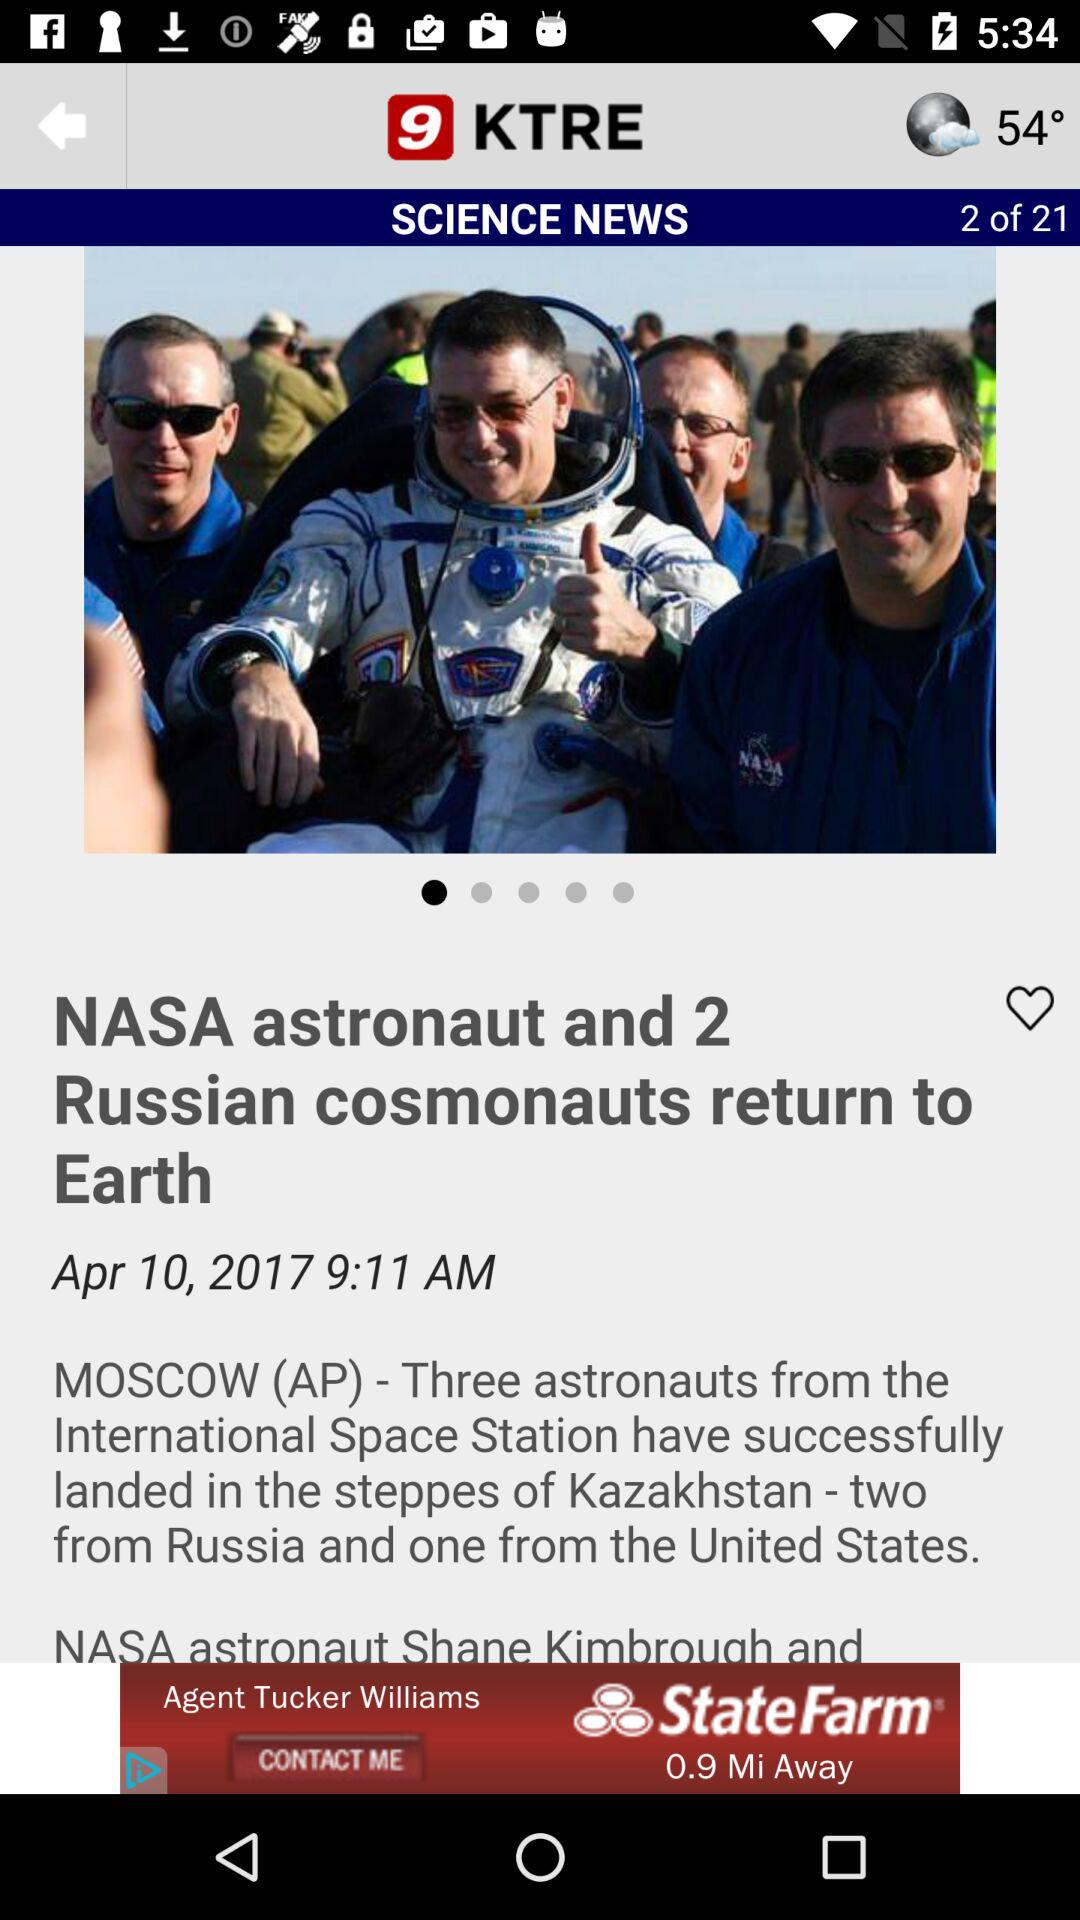Where did the astronauts land from the International Space Station? The astronauts from the International Space Station have landed in the steppes of Kazakhstan. 